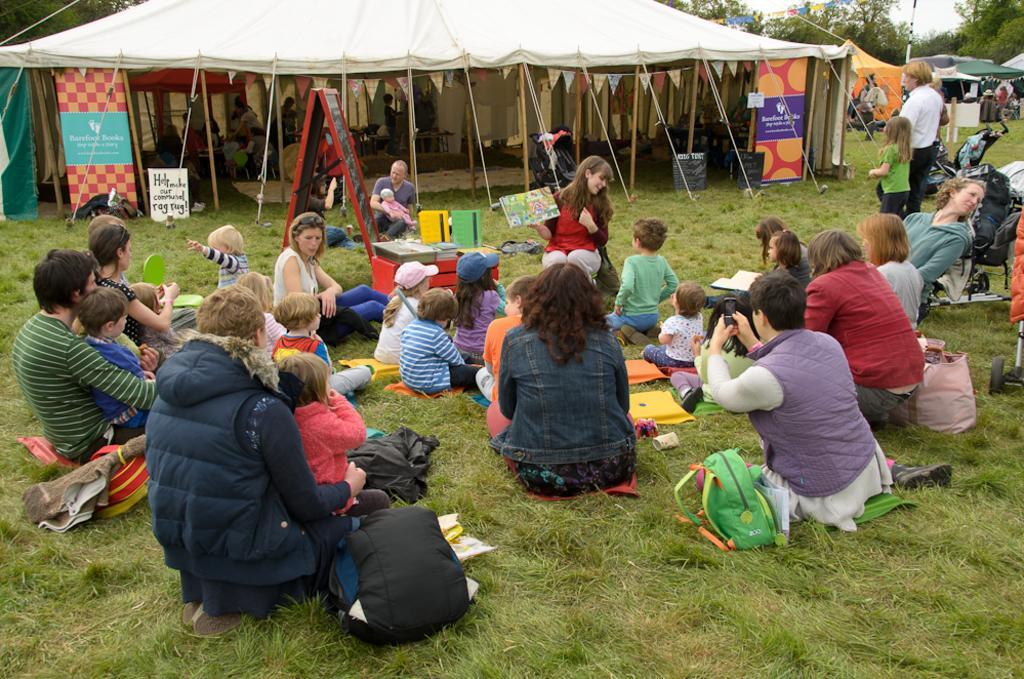Can you describe this image briefly? In this image I see number of people who are sitting and I see the green grass and I see few people people are standing and I see few bags. In the background I see the tents and I see few banners and I see 2 boards and I see the trees. 